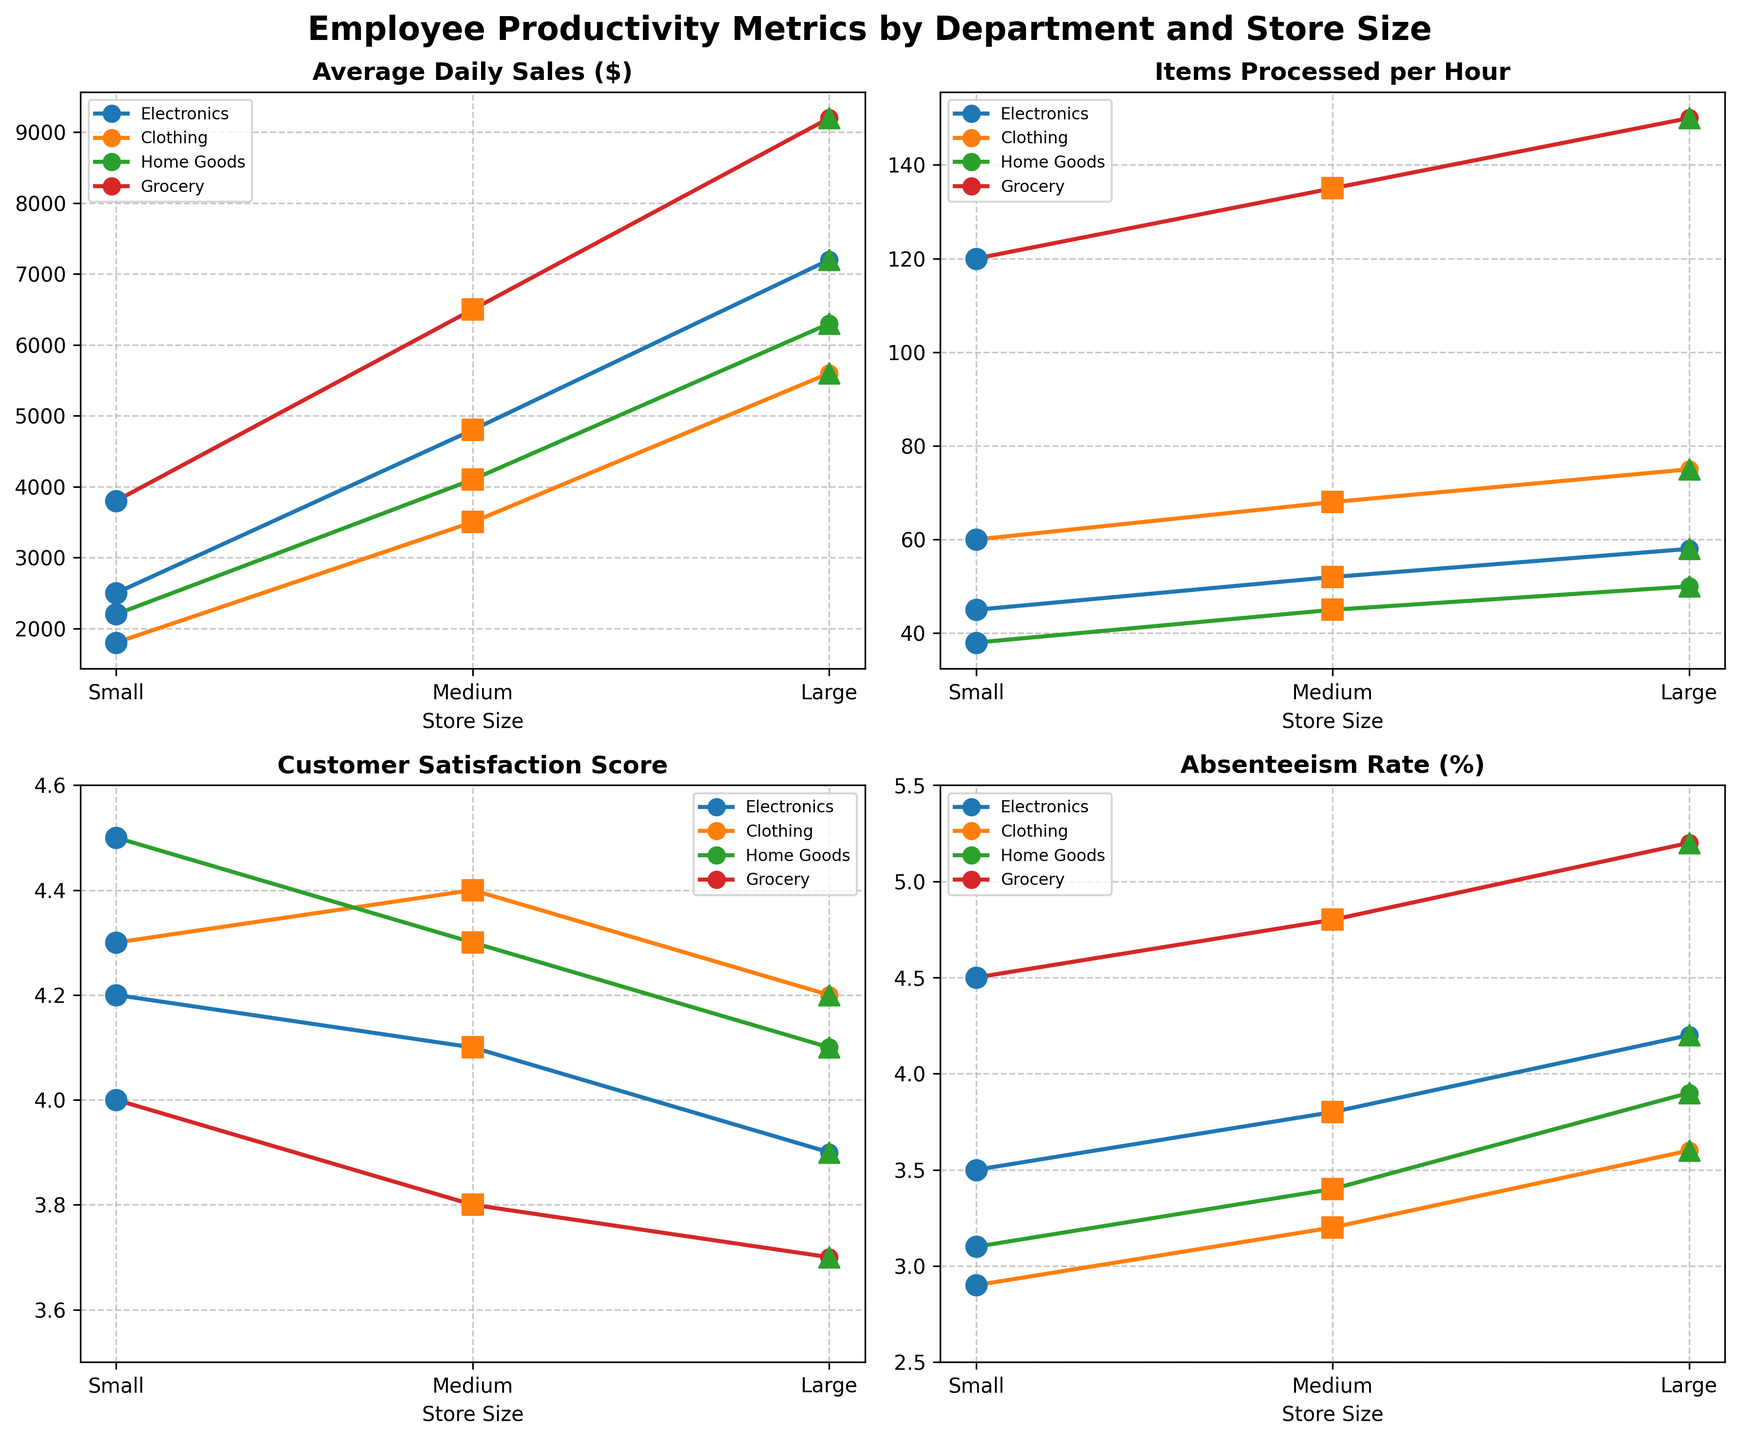What is the title of the figure? The title is prominently displayed at the top of the figure. It helps the viewer understand the overall context.
Answer: Employee Productivity Metrics by Department and Store Size Which department has the highest customer satisfaction score in large stores? Look at the subplot for Customer Satisfaction Score. Identify the largest store size and find its maximum score.
Answer: Clothing How does absenteeism rate compare between small and large Grocery stores? Observe the subplot for Absenteeism Rate (%). Compare data points for small and large Grocery stores.
Answer: Small stores have a lower absenteeism rate than large stores What trend can be observed in the Electronics department for Average Daily Sales across different store sizes? Look at the subplot for Average Daily Sales ($) and follow Electronics data points across Small, Medium, and Large sizes.
Answer: Sales increase as store size increases Which department processes the most items per hour in medium-sized stores? Examine the subplot for Items Processed per Hour and find the maximum in the medium store size column.
Answer: Grocery Compare the absenteeism rates of Electronics and Home Goods departments in medium-sized stores. Look at the subplot for Absenteeism Rate (%). Compare the data points for Electronics and Home Goods in medium-sized stores.
Answer: Electronics has a slightly higher absenteeism rate than Home Goods What is the average customer satisfaction score for all departments in small stores? Sum the customer satisfaction scores for all departments in small stores and divide by the number of departments (4).
Answer: 4.25 Is there a department that shows a steady increase in Items Processed per Hour across all store sizes? Look at the subplot for Items Processed per Hour. Identify any department with consistently increasing values from Small to Large store sizes.
Answer: Clothing and Grocery both show a steady increase Compare the Average Daily Sales of the Home Goods department in small and large stores. Observe the subplot for Average Daily Sales ($) and note the values for small and large stores in Home Goods. Calculate the difference.
Answer: Large stores have $4100 more in sales than small stores 